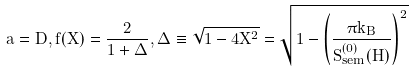Convert formula to latex. <formula><loc_0><loc_0><loc_500><loc_500>a = D , f ( X ) = \frac { 2 } { 1 + \Delta } , \Delta \equiv \sqrt { 1 - 4 X ^ { 2 } } = \sqrt { 1 - \left ( \frac { \pi k _ { B } } { S _ { s e m } ^ { ( 0 ) } ( H ) } \right ) ^ { 2 } }</formula> 